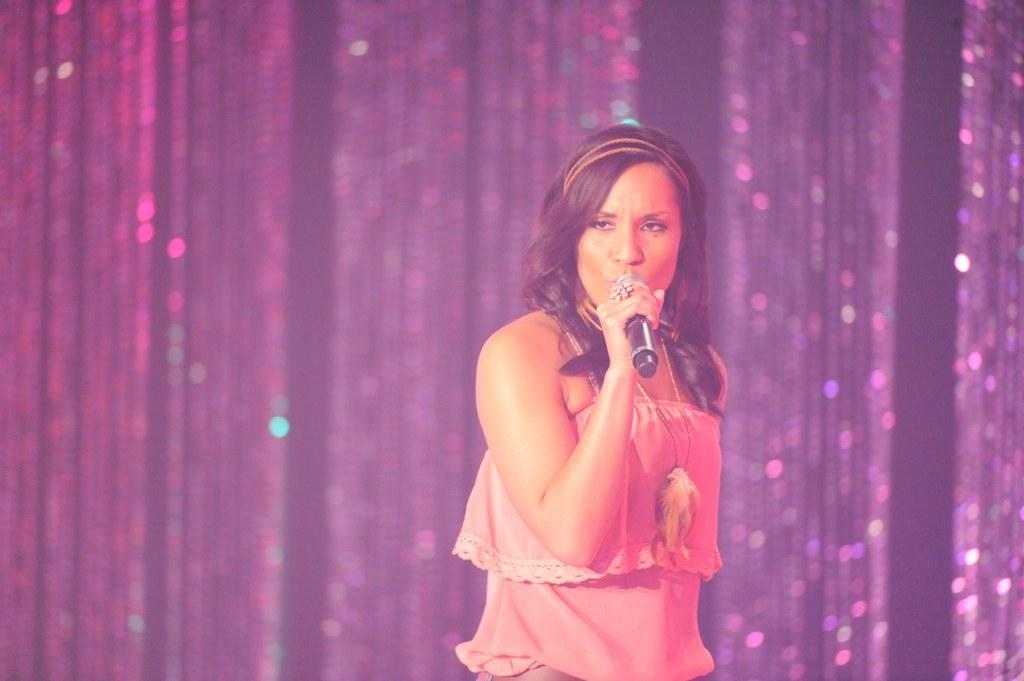What is the person in the image doing? The person is standing in the image and holding a mic. What can be seen behind the person? There are curtains at the back of the person. What effect does the father have on the achiever in the image? There is no father or achiever present in the image, so it is not possible to determine any effect. 